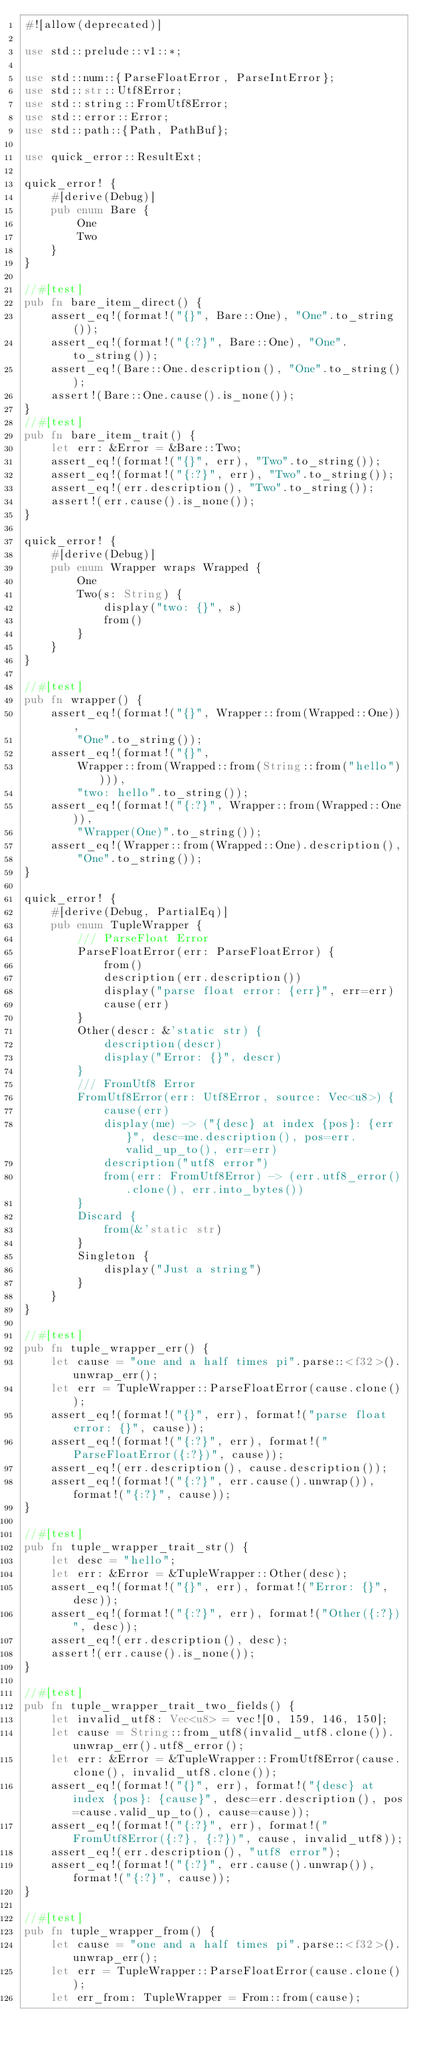Convert code to text. <code><loc_0><loc_0><loc_500><loc_500><_Rust_>#![allow(deprecated)]

use std::prelude::v1::*;

use std::num::{ParseFloatError, ParseIntError};
use std::str::Utf8Error;
use std::string::FromUtf8Error;
use std::error::Error;
use std::path::{Path, PathBuf};

use quick_error::ResultExt;

quick_error! {
    #[derive(Debug)]
    pub enum Bare {
        One
        Two
    }
}

//#[test]
pub fn bare_item_direct() {
    assert_eq!(format!("{}", Bare::One), "One".to_string());
    assert_eq!(format!("{:?}", Bare::One), "One".to_string());
    assert_eq!(Bare::One.description(), "One".to_string());
    assert!(Bare::One.cause().is_none());
}
//#[test]
pub fn bare_item_trait() {
    let err: &Error = &Bare::Two;
    assert_eq!(format!("{}", err), "Two".to_string());
    assert_eq!(format!("{:?}", err), "Two".to_string());
    assert_eq!(err.description(), "Two".to_string());
    assert!(err.cause().is_none());
}

quick_error! {
    #[derive(Debug)]
    pub enum Wrapper wraps Wrapped {
        One
        Two(s: String) {
            display("two: {}", s)
            from()
        }
    }
}

//#[test]
pub fn wrapper() {
    assert_eq!(format!("{}", Wrapper::from(Wrapped::One)),
        "One".to_string());
    assert_eq!(format!("{}",
        Wrapper::from(Wrapped::from(String::from("hello")))),
        "two: hello".to_string());
    assert_eq!(format!("{:?}", Wrapper::from(Wrapped::One)),
        "Wrapper(One)".to_string());
    assert_eq!(Wrapper::from(Wrapped::One).description(),
        "One".to_string());
}

quick_error! {
    #[derive(Debug, PartialEq)]
    pub enum TupleWrapper {
        /// ParseFloat Error
        ParseFloatError(err: ParseFloatError) {
            from()
            description(err.description())
            display("parse float error: {err}", err=err)
            cause(err)
        }
        Other(descr: &'static str) {
            description(descr)
            display("Error: {}", descr)
        }
        /// FromUtf8 Error
        FromUtf8Error(err: Utf8Error, source: Vec<u8>) {
            cause(err)
            display(me) -> ("{desc} at index {pos}: {err}", desc=me.description(), pos=err.valid_up_to(), err=err)
            description("utf8 error")
            from(err: FromUtf8Error) -> (err.utf8_error().clone(), err.into_bytes())
        }
        Discard {
            from(&'static str)
        }
        Singleton {
            display("Just a string")
        }
    }
}

//#[test]
pub fn tuple_wrapper_err() {
    let cause = "one and a half times pi".parse::<f32>().unwrap_err();
    let err = TupleWrapper::ParseFloatError(cause.clone());
    assert_eq!(format!("{}", err), format!("parse float error: {}", cause));
    assert_eq!(format!("{:?}", err), format!("ParseFloatError({:?})", cause));
    assert_eq!(err.description(), cause.description());
    assert_eq!(format!("{:?}", err.cause().unwrap()), format!("{:?}", cause));
}

//#[test]
pub fn tuple_wrapper_trait_str() {
    let desc = "hello";
    let err: &Error = &TupleWrapper::Other(desc);
    assert_eq!(format!("{}", err), format!("Error: {}", desc));
    assert_eq!(format!("{:?}", err), format!("Other({:?})", desc));
    assert_eq!(err.description(), desc);
    assert!(err.cause().is_none());
}

//#[test]
pub fn tuple_wrapper_trait_two_fields() {
    let invalid_utf8: Vec<u8> = vec![0, 159, 146, 150];
    let cause = String::from_utf8(invalid_utf8.clone()).unwrap_err().utf8_error();
    let err: &Error = &TupleWrapper::FromUtf8Error(cause.clone(), invalid_utf8.clone());
    assert_eq!(format!("{}", err), format!("{desc} at index {pos}: {cause}", desc=err.description(), pos=cause.valid_up_to(), cause=cause));
    assert_eq!(format!("{:?}", err), format!("FromUtf8Error({:?}, {:?})", cause, invalid_utf8));
    assert_eq!(err.description(), "utf8 error");
    assert_eq!(format!("{:?}", err.cause().unwrap()), format!("{:?}", cause));
}

//#[test]
pub fn tuple_wrapper_from() {
    let cause = "one and a half times pi".parse::<f32>().unwrap_err();
    let err = TupleWrapper::ParseFloatError(cause.clone());
    let err_from: TupleWrapper = From::from(cause);</code> 